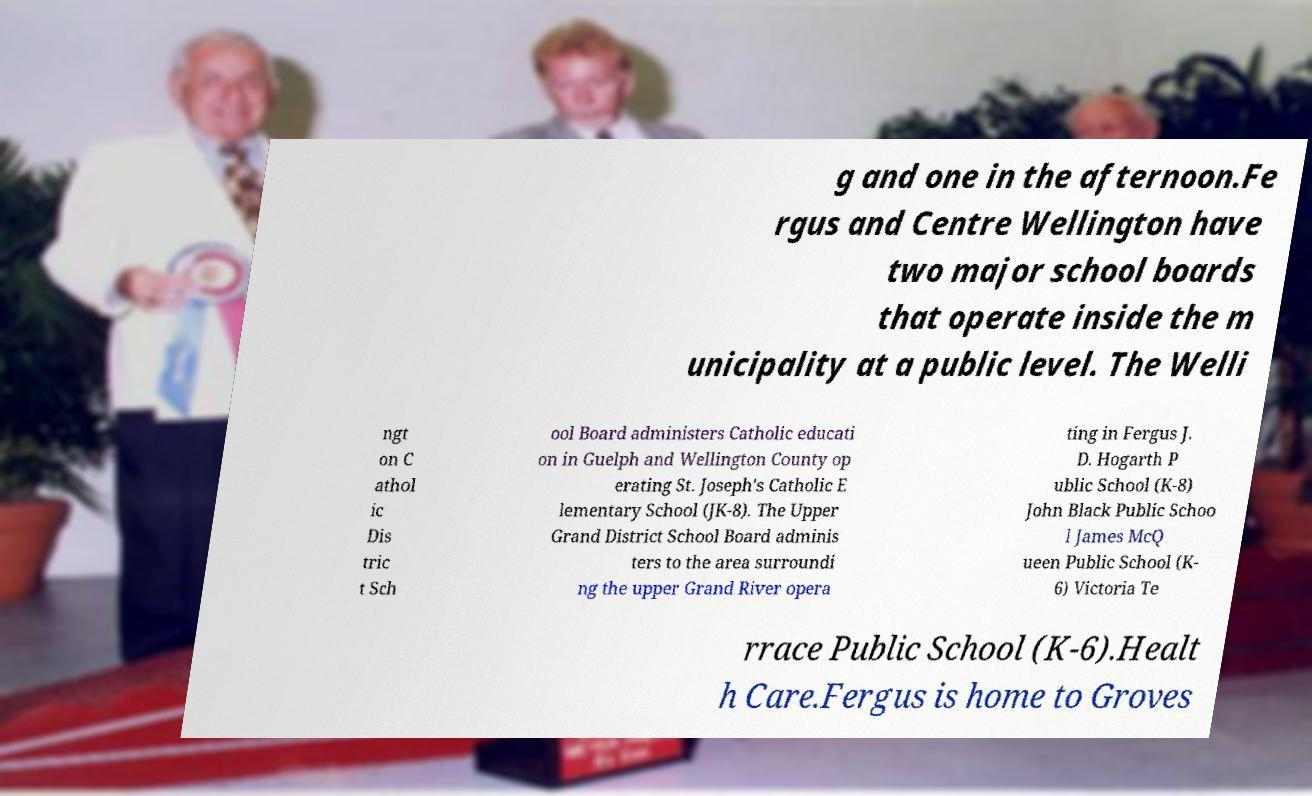I need the written content from this picture converted into text. Can you do that? g and one in the afternoon.Fe rgus and Centre Wellington have two major school boards that operate inside the m unicipality at a public level. The Welli ngt on C athol ic Dis tric t Sch ool Board administers Catholic educati on in Guelph and Wellington County op erating St. Joseph's Catholic E lementary School (JK-8). The Upper Grand District School Board adminis ters to the area surroundi ng the upper Grand River opera ting in Fergus J. D. Hogarth P ublic School (K-8) John Black Public Schoo l James McQ ueen Public School (K- 6) Victoria Te rrace Public School (K-6).Healt h Care.Fergus is home to Groves 